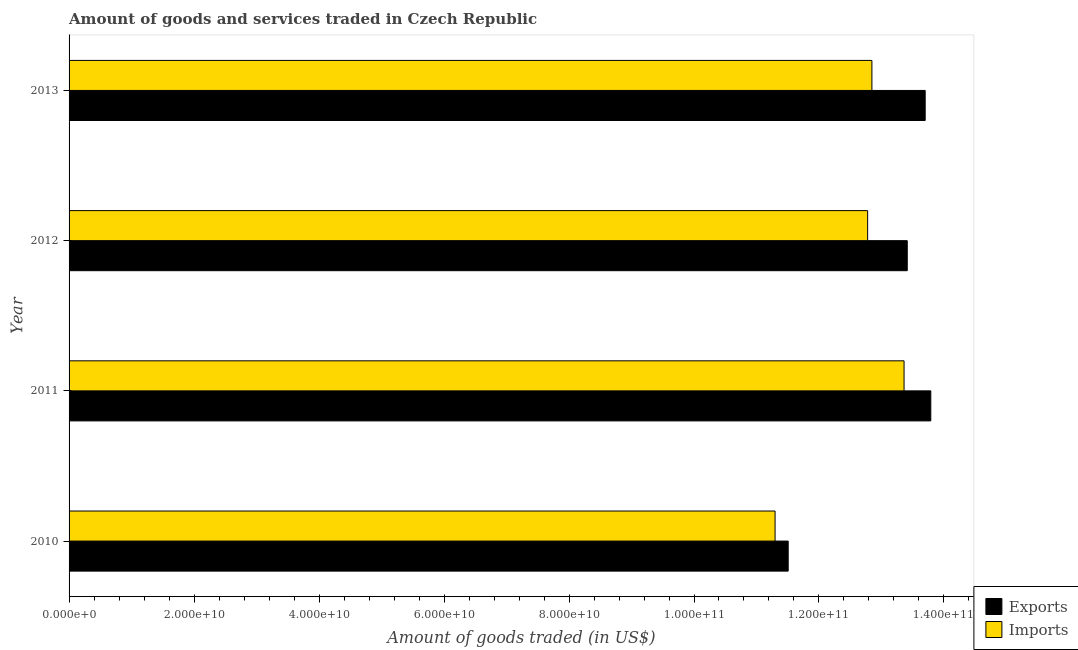How many different coloured bars are there?
Your answer should be very brief. 2. Are the number of bars per tick equal to the number of legend labels?
Your response must be concise. Yes. How many bars are there on the 1st tick from the top?
Make the answer very short. 2. How many bars are there on the 3rd tick from the bottom?
Provide a short and direct response. 2. In how many cases, is the number of bars for a given year not equal to the number of legend labels?
Make the answer very short. 0. What is the amount of goods imported in 2012?
Ensure brevity in your answer.  1.28e+11. Across all years, what is the maximum amount of goods exported?
Provide a short and direct response. 1.38e+11. Across all years, what is the minimum amount of goods exported?
Offer a very short reply. 1.15e+11. In which year was the amount of goods imported maximum?
Provide a succinct answer. 2011. What is the total amount of goods exported in the graph?
Provide a short and direct response. 5.24e+11. What is the difference between the amount of goods exported in 2011 and that in 2013?
Offer a very short reply. 8.98e+08. What is the difference between the amount of goods imported in 2011 and the amount of goods exported in 2012?
Provide a succinct answer. -5.09e+08. What is the average amount of goods imported per year?
Offer a very short reply. 1.26e+11. In the year 2013, what is the difference between the amount of goods exported and amount of goods imported?
Give a very brief answer. 8.53e+09. In how many years, is the amount of goods exported greater than 76000000000 US$?
Offer a very short reply. 4. What is the ratio of the amount of goods exported in 2010 to that in 2013?
Ensure brevity in your answer.  0.84. Is the amount of goods exported in 2010 less than that in 2013?
Offer a very short reply. Yes. What is the difference between the highest and the second highest amount of goods imported?
Provide a succinct answer. 5.15e+09. What is the difference between the highest and the lowest amount of goods imported?
Offer a very short reply. 2.06e+1. What does the 1st bar from the top in 2013 represents?
Your response must be concise. Imports. What does the 1st bar from the bottom in 2011 represents?
Your answer should be very brief. Exports. How many years are there in the graph?
Your answer should be compact. 4. Are the values on the major ticks of X-axis written in scientific E-notation?
Provide a succinct answer. Yes. Does the graph contain any zero values?
Offer a very short reply. No. What is the title of the graph?
Keep it short and to the point. Amount of goods and services traded in Czech Republic. What is the label or title of the X-axis?
Offer a very short reply. Amount of goods traded (in US$). What is the label or title of the Y-axis?
Offer a very short reply. Year. What is the Amount of goods traded (in US$) of Exports in 2010?
Offer a very short reply. 1.15e+11. What is the Amount of goods traded (in US$) in Imports in 2010?
Provide a short and direct response. 1.13e+11. What is the Amount of goods traded (in US$) in Exports in 2011?
Give a very brief answer. 1.38e+11. What is the Amount of goods traded (in US$) in Imports in 2011?
Offer a terse response. 1.34e+11. What is the Amount of goods traded (in US$) of Exports in 2012?
Provide a succinct answer. 1.34e+11. What is the Amount of goods traded (in US$) of Imports in 2012?
Ensure brevity in your answer.  1.28e+11. What is the Amount of goods traded (in US$) in Exports in 2013?
Provide a succinct answer. 1.37e+11. What is the Amount of goods traded (in US$) in Imports in 2013?
Ensure brevity in your answer.  1.28e+11. Across all years, what is the maximum Amount of goods traded (in US$) of Exports?
Your response must be concise. 1.38e+11. Across all years, what is the maximum Amount of goods traded (in US$) of Imports?
Your answer should be very brief. 1.34e+11. Across all years, what is the minimum Amount of goods traded (in US$) in Exports?
Keep it short and to the point. 1.15e+11. Across all years, what is the minimum Amount of goods traded (in US$) in Imports?
Offer a terse response. 1.13e+11. What is the total Amount of goods traded (in US$) of Exports in the graph?
Your answer should be compact. 5.24e+11. What is the total Amount of goods traded (in US$) of Imports in the graph?
Make the answer very short. 5.03e+11. What is the difference between the Amount of goods traded (in US$) in Exports in 2010 and that in 2011?
Your response must be concise. -2.28e+1. What is the difference between the Amount of goods traded (in US$) of Imports in 2010 and that in 2011?
Offer a very short reply. -2.06e+1. What is the difference between the Amount of goods traded (in US$) in Exports in 2010 and that in 2012?
Your answer should be compact. -1.91e+1. What is the difference between the Amount of goods traded (in US$) in Imports in 2010 and that in 2012?
Provide a short and direct response. -1.48e+1. What is the difference between the Amount of goods traded (in US$) in Exports in 2010 and that in 2013?
Your answer should be compact. -2.19e+1. What is the difference between the Amount of goods traded (in US$) in Imports in 2010 and that in 2013?
Ensure brevity in your answer.  -1.55e+1. What is the difference between the Amount of goods traded (in US$) of Exports in 2011 and that in 2012?
Keep it short and to the point. 3.77e+09. What is the difference between the Amount of goods traded (in US$) in Imports in 2011 and that in 2012?
Make the answer very short. 5.83e+09. What is the difference between the Amount of goods traded (in US$) in Exports in 2011 and that in 2013?
Offer a very short reply. 8.98e+08. What is the difference between the Amount of goods traded (in US$) of Imports in 2011 and that in 2013?
Give a very brief answer. 5.15e+09. What is the difference between the Amount of goods traded (in US$) in Exports in 2012 and that in 2013?
Your response must be concise. -2.87e+09. What is the difference between the Amount of goods traded (in US$) of Imports in 2012 and that in 2013?
Offer a terse response. -6.83e+08. What is the difference between the Amount of goods traded (in US$) in Exports in 2010 and the Amount of goods traded (in US$) in Imports in 2011?
Offer a terse response. -1.85e+1. What is the difference between the Amount of goods traded (in US$) of Exports in 2010 and the Amount of goods traded (in US$) of Imports in 2012?
Provide a succinct answer. -1.27e+1. What is the difference between the Amount of goods traded (in US$) in Exports in 2010 and the Amount of goods traded (in US$) in Imports in 2013?
Ensure brevity in your answer.  -1.34e+1. What is the difference between the Amount of goods traded (in US$) of Exports in 2011 and the Amount of goods traded (in US$) of Imports in 2012?
Make the answer very short. 1.01e+1. What is the difference between the Amount of goods traded (in US$) of Exports in 2011 and the Amount of goods traded (in US$) of Imports in 2013?
Offer a very short reply. 9.42e+09. What is the difference between the Amount of goods traded (in US$) of Exports in 2012 and the Amount of goods traded (in US$) of Imports in 2013?
Keep it short and to the point. 5.66e+09. What is the average Amount of goods traded (in US$) of Exports per year?
Offer a very short reply. 1.31e+11. What is the average Amount of goods traded (in US$) in Imports per year?
Your answer should be very brief. 1.26e+11. In the year 2010, what is the difference between the Amount of goods traded (in US$) in Exports and Amount of goods traded (in US$) in Imports?
Make the answer very short. 2.10e+09. In the year 2011, what is the difference between the Amount of goods traded (in US$) of Exports and Amount of goods traded (in US$) of Imports?
Your response must be concise. 4.28e+09. In the year 2012, what is the difference between the Amount of goods traded (in US$) of Exports and Amount of goods traded (in US$) of Imports?
Give a very brief answer. 6.34e+09. In the year 2013, what is the difference between the Amount of goods traded (in US$) of Exports and Amount of goods traded (in US$) of Imports?
Provide a succinct answer. 8.53e+09. What is the ratio of the Amount of goods traded (in US$) in Exports in 2010 to that in 2011?
Keep it short and to the point. 0.83. What is the ratio of the Amount of goods traded (in US$) in Imports in 2010 to that in 2011?
Offer a terse response. 0.85. What is the ratio of the Amount of goods traded (in US$) of Exports in 2010 to that in 2012?
Ensure brevity in your answer.  0.86. What is the ratio of the Amount of goods traded (in US$) of Imports in 2010 to that in 2012?
Make the answer very short. 0.88. What is the ratio of the Amount of goods traded (in US$) of Exports in 2010 to that in 2013?
Provide a short and direct response. 0.84. What is the ratio of the Amount of goods traded (in US$) in Imports in 2010 to that in 2013?
Provide a succinct answer. 0.88. What is the ratio of the Amount of goods traded (in US$) of Exports in 2011 to that in 2012?
Provide a short and direct response. 1.03. What is the ratio of the Amount of goods traded (in US$) in Imports in 2011 to that in 2012?
Give a very brief answer. 1.05. What is the ratio of the Amount of goods traded (in US$) of Exports in 2011 to that in 2013?
Make the answer very short. 1.01. What is the ratio of the Amount of goods traded (in US$) in Imports in 2011 to that in 2013?
Provide a succinct answer. 1.04. What is the ratio of the Amount of goods traded (in US$) of Exports in 2012 to that in 2013?
Keep it short and to the point. 0.98. What is the ratio of the Amount of goods traded (in US$) in Imports in 2012 to that in 2013?
Your answer should be very brief. 0.99. What is the difference between the highest and the second highest Amount of goods traded (in US$) of Exports?
Keep it short and to the point. 8.98e+08. What is the difference between the highest and the second highest Amount of goods traded (in US$) of Imports?
Your answer should be very brief. 5.15e+09. What is the difference between the highest and the lowest Amount of goods traded (in US$) in Exports?
Keep it short and to the point. 2.28e+1. What is the difference between the highest and the lowest Amount of goods traded (in US$) in Imports?
Your response must be concise. 2.06e+1. 